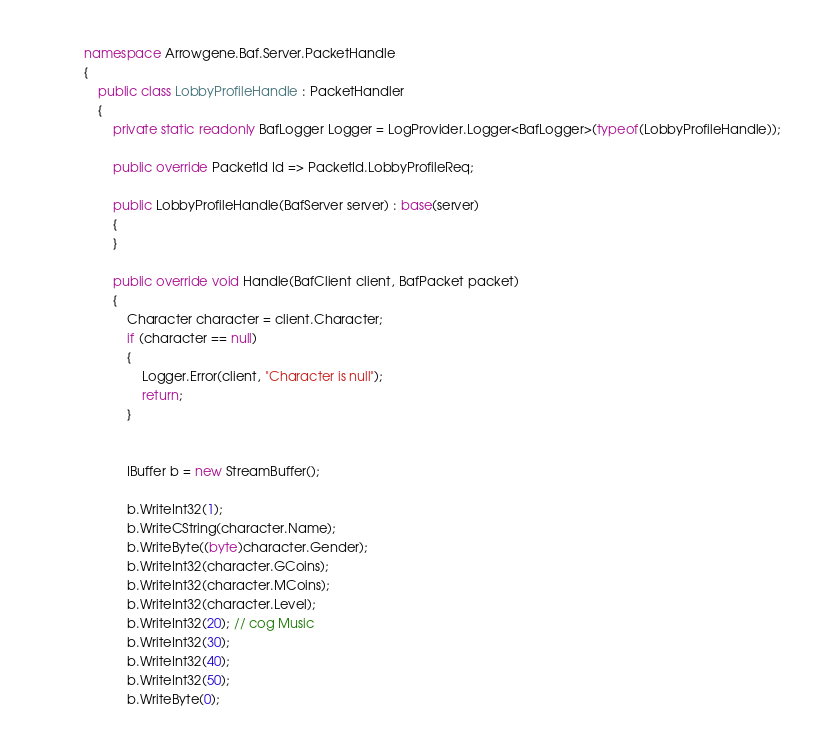<code> <loc_0><loc_0><loc_500><loc_500><_C#_>namespace Arrowgene.Baf.Server.PacketHandle
{
    public class LobbyProfileHandle : PacketHandler
    {
        private static readonly BafLogger Logger = LogProvider.Logger<BafLogger>(typeof(LobbyProfileHandle));

        public override PacketId Id => PacketId.LobbyProfileReq;

        public LobbyProfileHandle(BafServer server) : base(server)
        {
        }
        
        public override void Handle(BafClient client, BafPacket packet)
        {
            Character character = client.Character;
            if (character == null)
            {
                Logger.Error(client, "Character is null");
                return;
            }
            
            
            IBuffer b = new StreamBuffer();

            b.WriteInt32(1);
            b.WriteCString(character.Name);
            b.WriteByte((byte)character.Gender);
            b.WriteInt32(character.GCoins);
            b.WriteInt32(character.MCoins);
            b.WriteInt32(character.Level);
            b.WriteInt32(20); // cog Music
            b.WriteInt32(30);
            b.WriteInt32(40);
            b.WriteInt32(50);
            b.WriteByte(0);</code> 